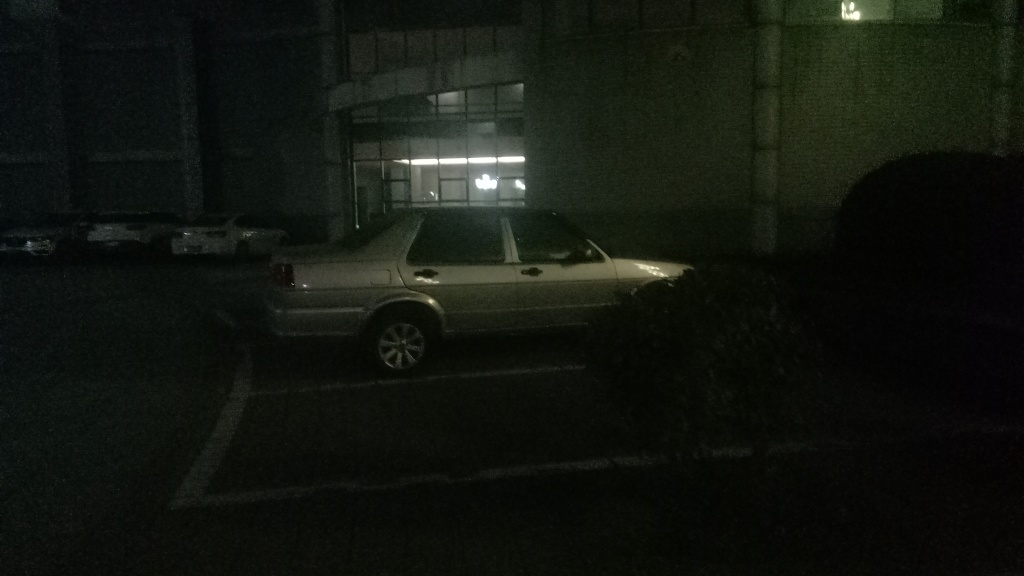What can we infer about the location where this photo was taken? The photo seems to have been taken in a parking area adjacent to a building, possibly a commercial or industrial facility given the large doors and the structured design of the facade. It's likely to be after business hours as the area is not well lit and the building itself does not show signs of activity. 